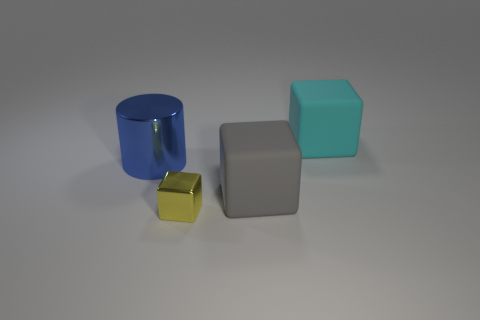Add 1 small green cylinders. How many objects exist? 5 Subtract all cylinders. How many objects are left? 3 Add 2 blue objects. How many blue objects are left? 3 Add 4 small metal cubes. How many small metal cubes exist? 5 Subtract 0 gray cylinders. How many objects are left? 4 Subtract all big gray rubber objects. Subtract all rubber cubes. How many objects are left? 1 